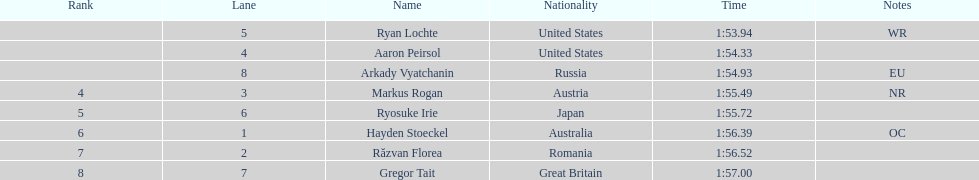Did austria or russia rank higher? Russia. 